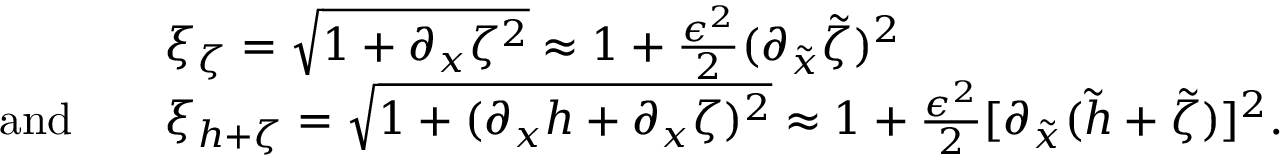Convert formula to latex. <formula><loc_0><loc_0><loc_500><loc_500>\begin{array} { r l } & { \xi _ { \zeta } = \sqrt { 1 + \partial _ { x } \zeta ^ { 2 } } \approx 1 + \frac { \epsilon ^ { 2 } } { 2 } ( \partial _ { \tilde { x } } \tilde { \zeta } ) ^ { 2 } } \\ { a n d \quad } & { \xi _ { h + \zeta } = \sqrt { 1 + ( \partial _ { x } h + \partial _ { x } \zeta ) ^ { 2 } } \approx 1 + \frac { \epsilon ^ { 2 } } { 2 } [ \partial _ { \tilde { x } } ( \tilde { h } + \tilde { \zeta } ) ] ^ { 2 } . } \end{array}</formula> 